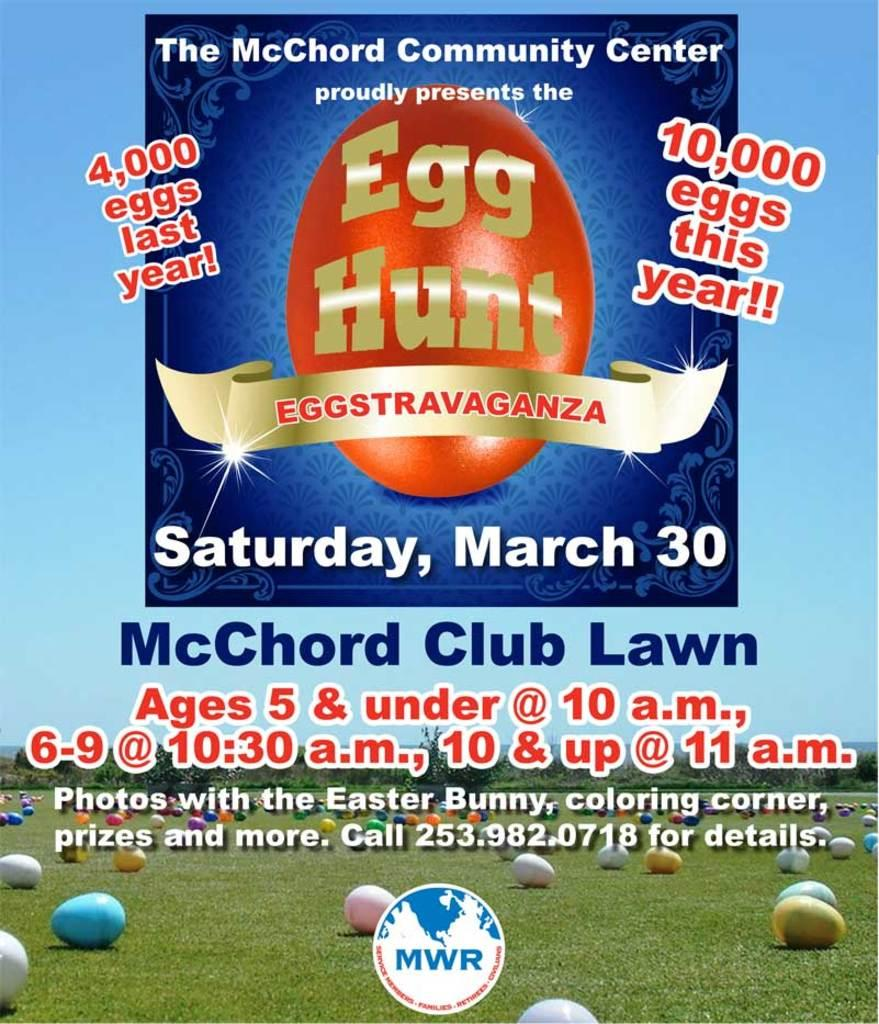<image>
Describe the image concisely. An Egg hunt is advertised for March 30th. 